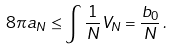Convert formula to latex. <formula><loc_0><loc_0><loc_500><loc_500>8 \pi a _ { N } \leq \int \frac { 1 } { N } V _ { N } = \frac { b _ { 0 } } { N } \, .</formula> 